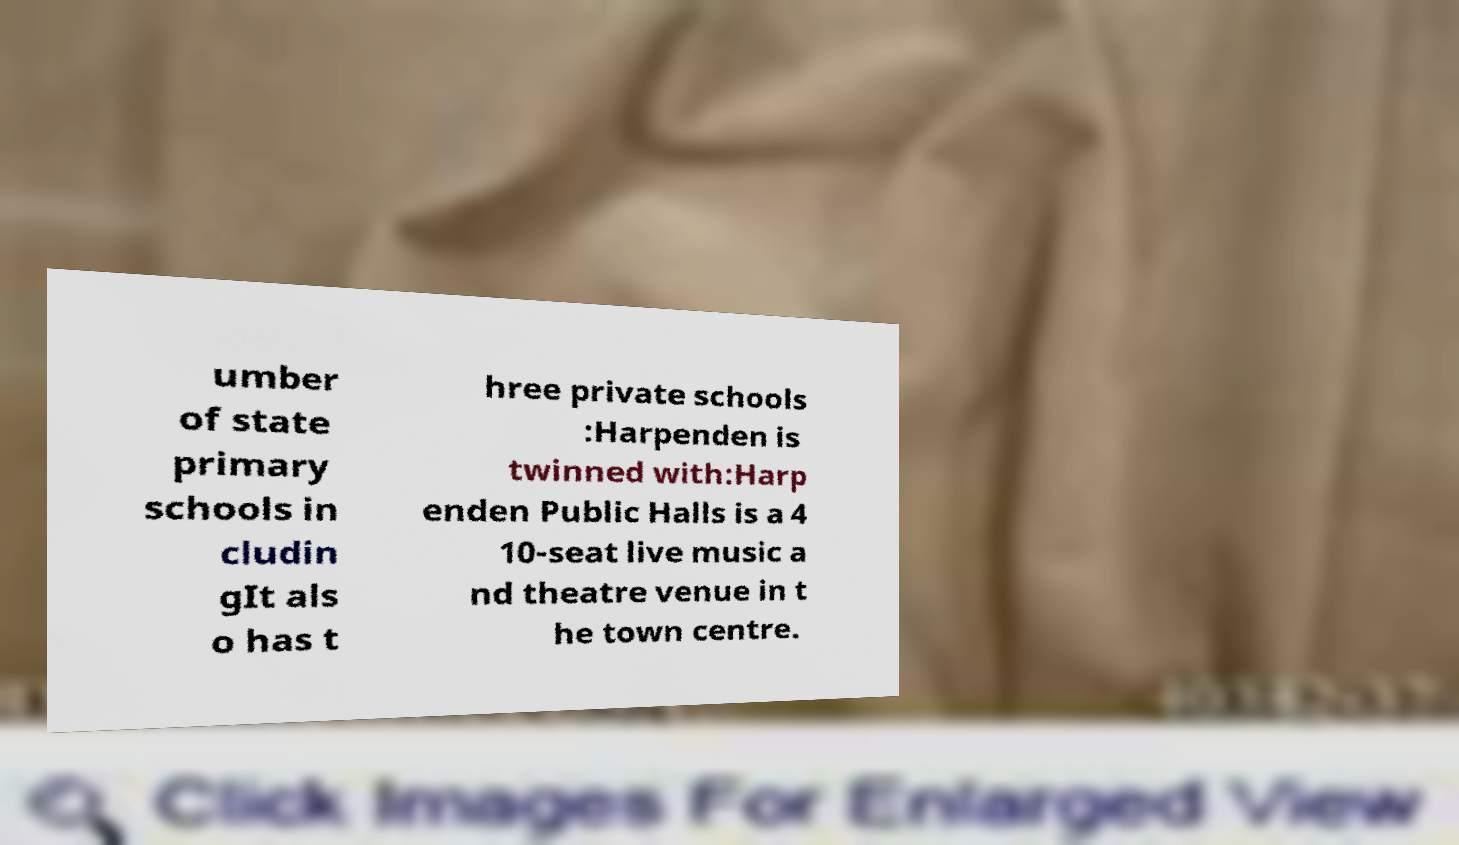What messages or text are displayed in this image? I need them in a readable, typed format. umber of state primary schools in cludin gIt als o has t hree private schools :Harpenden is twinned with:Harp enden Public Halls is a 4 10-seat live music a nd theatre venue in t he town centre. 